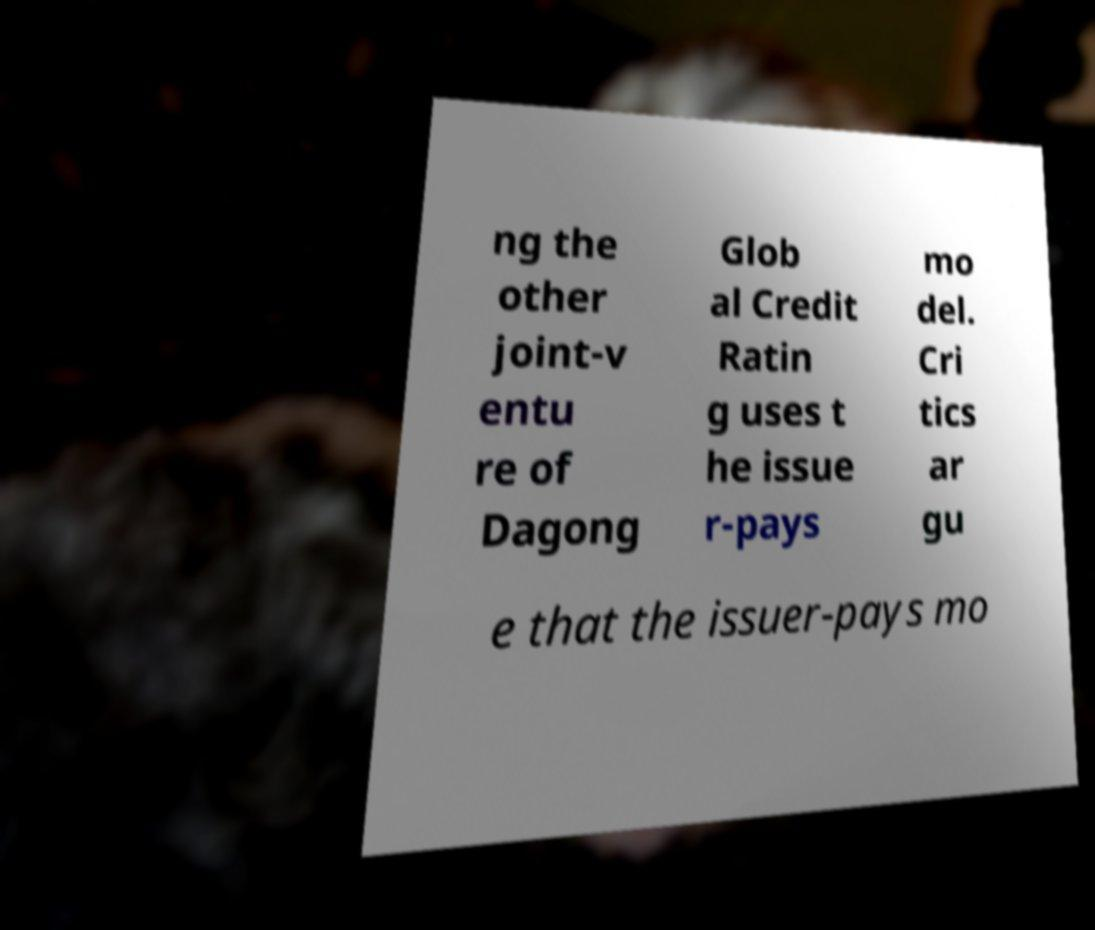Could you assist in decoding the text presented in this image and type it out clearly? ng the other joint-v entu re of Dagong Glob al Credit Ratin g uses t he issue r-pays mo del. Cri tics ar gu e that the issuer-pays mo 